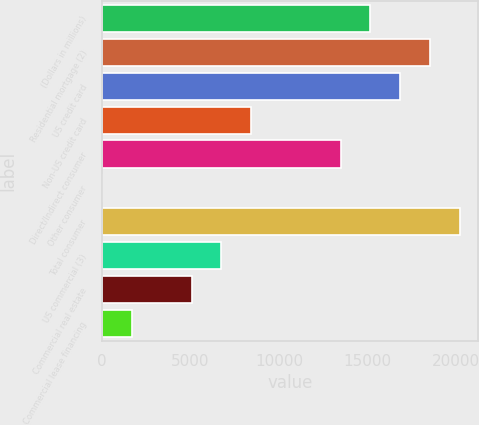Convert chart to OTSL. <chart><loc_0><loc_0><loc_500><loc_500><bar_chart><fcel>(Dollars in millions)<fcel>Residential mortgage (2)<fcel>US credit card<fcel>Non-US credit card<fcel>Direct/Indirect consumer<fcel>Other consumer<fcel>Total consumer<fcel>US commercial (3)<fcel>Commercial real estate<fcel>Commercial lease financing<nl><fcel>15174.3<fcel>18545.7<fcel>16860<fcel>8431.5<fcel>13488.6<fcel>3<fcel>20231.4<fcel>6745.8<fcel>5060.1<fcel>1688.7<nl></chart> 